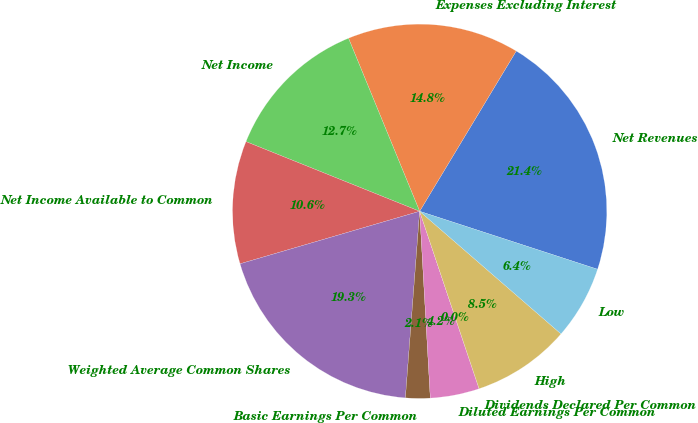<chart> <loc_0><loc_0><loc_500><loc_500><pie_chart><fcel>Net Revenues<fcel>Expenses Excluding Interest<fcel>Net Income<fcel>Net Income Available to Common<fcel>Weighted Average Common Shares<fcel>Basic Earnings Per Common<fcel>Diluted Earnings Per Common<fcel>Dividends Declared Per Common<fcel>High<fcel>Low<nl><fcel>21.38%<fcel>14.84%<fcel>12.72%<fcel>10.6%<fcel>19.26%<fcel>2.12%<fcel>4.24%<fcel>0.0%<fcel>8.48%<fcel>6.36%<nl></chart> 